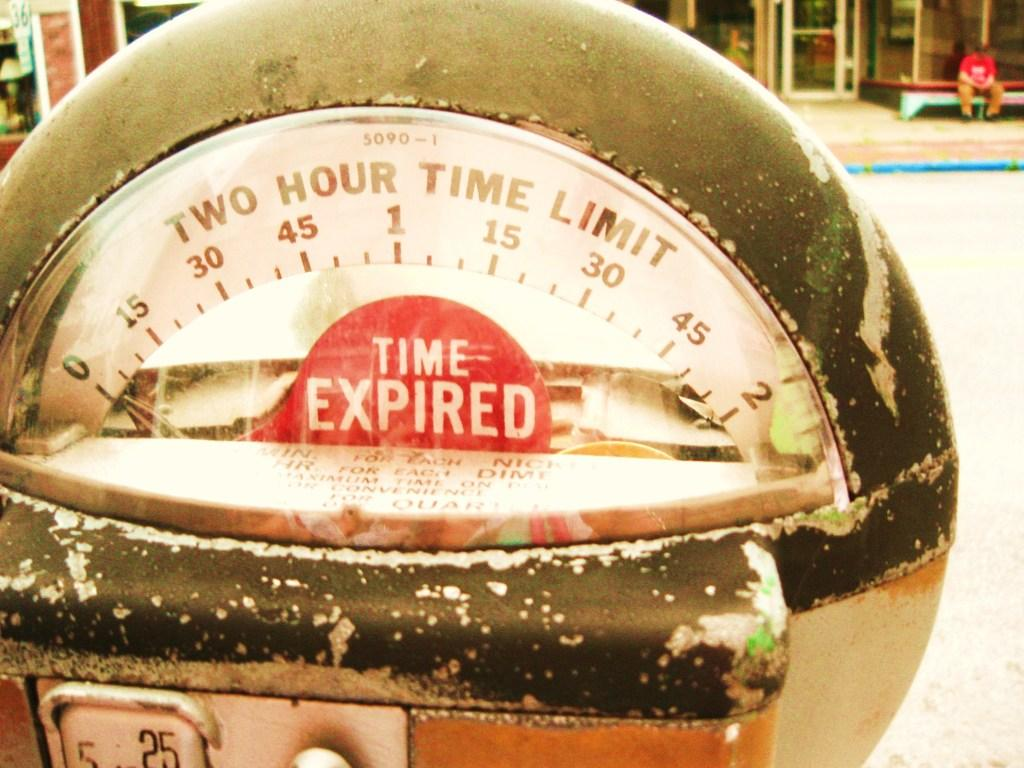Provide a one-sentence caption for the provided image. A closeup of a parking meter shows that the time has expired. 